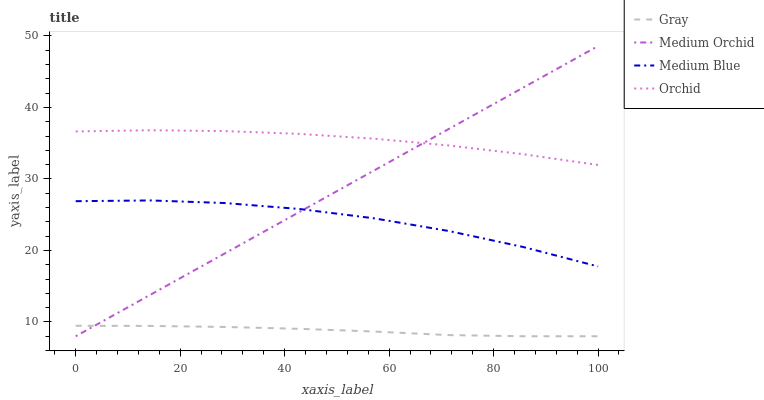Does Gray have the minimum area under the curve?
Answer yes or no. Yes. Does Orchid have the maximum area under the curve?
Answer yes or no. Yes. Does Medium Orchid have the minimum area under the curve?
Answer yes or no. No. Does Medium Orchid have the maximum area under the curve?
Answer yes or no. No. Is Medium Orchid the smoothest?
Answer yes or no. Yes. Is Medium Blue the roughest?
Answer yes or no. Yes. Is Medium Blue the smoothest?
Answer yes or no. No. Is Medium Orchid the roughest?
Answer yes or no. No. Does Gray have the lowest value?
Answer yes or no. Yes. Does Medium Blue have the lowest value?
Answer yes or no. No. Does Medium Orchid have the highest value?
Answer yes or no. Yes. Does Medium Blue have the highest value?
Answer yes or no. No. Is Gray less than Medium Blue?
Answer yes or no. Yes. Is Orchid greater than Medium Blue?
Answer yes or no. Yes. Does Medium Blue intersect Medium Orchid?
Answer yes or no. Yes. Is Medium Blue less than Medium Orchid?
Answer yes or no. No. Is Medium Blue greater than Medium Orchid?
Answer yes or no. No. Does Gray intersect Medium Blue?
Answer yes or no. No. 